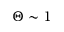<formula> <loc_0><loc_0><loc_500><loc_500>\Theta \sim 1</formula> 